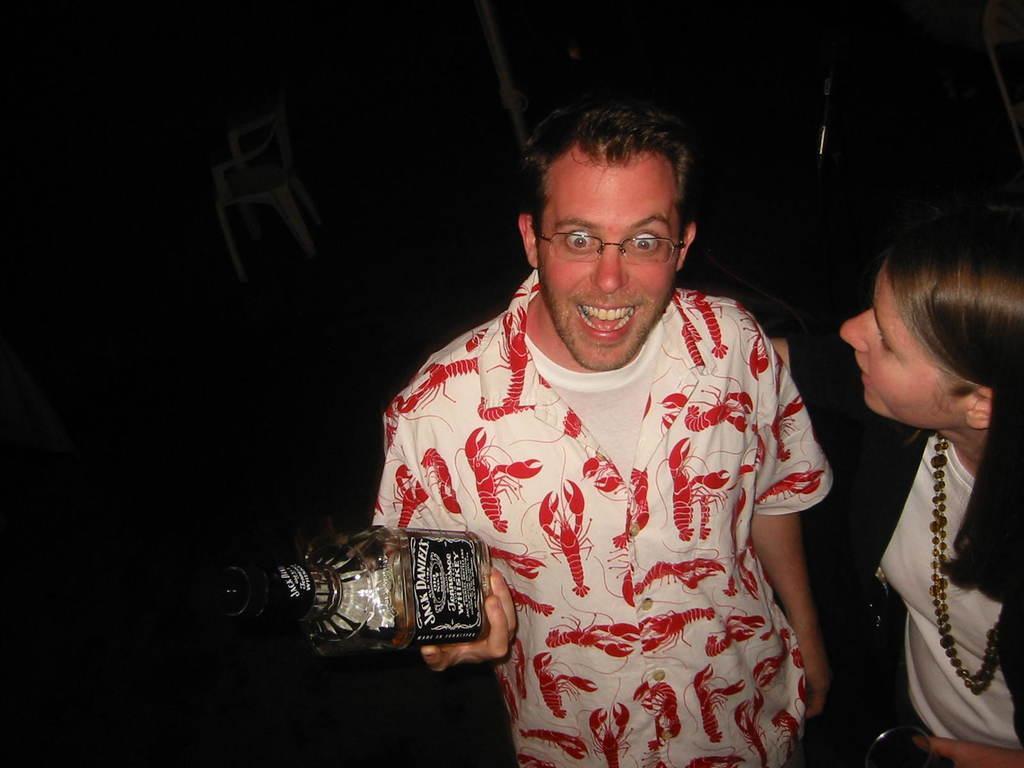Describe this image in one or two sentences. In this image there is a person holding a bottle, there is a person truncated towards the right of the image, there is a chair, the background of the image is dark. 